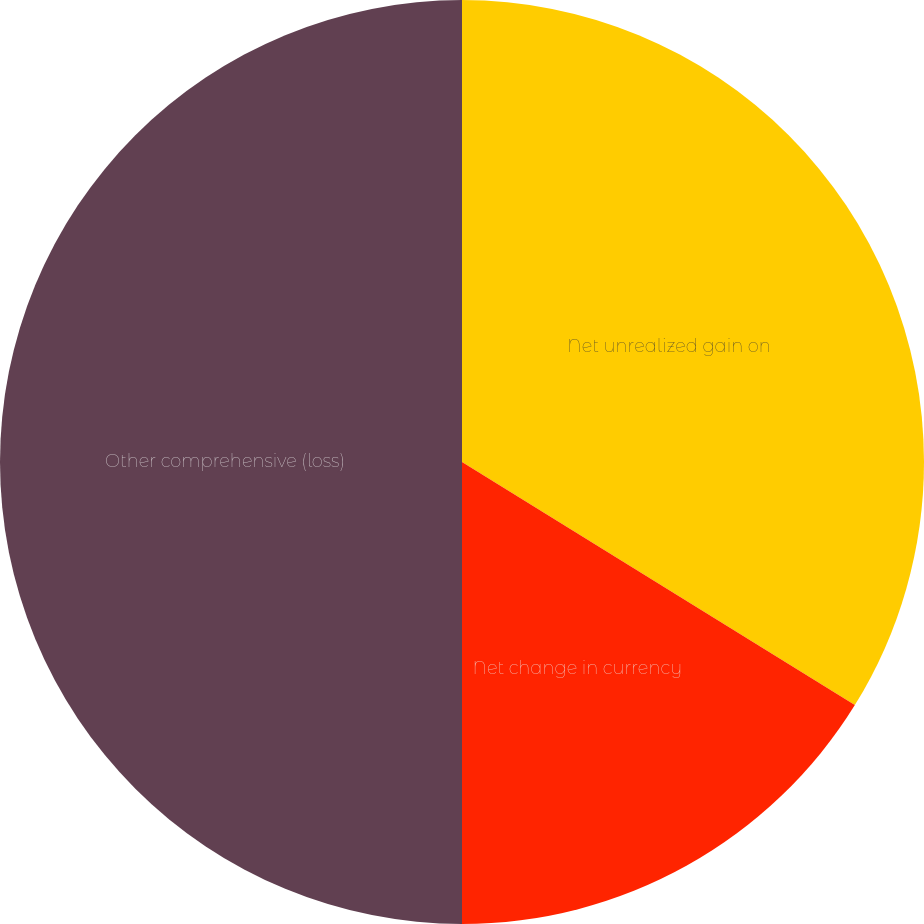Convert chart to OTSL. <chart><loc_0><loc_0><loc_500><loc_500><pie_chart><fcel>Net unrealized gain on<fcel>Net change in currency<fcel>Other comprehensive (loss)<nl><fcel>33.82%<fcel>16.18%<fcel>50.0%<nl></chart> 